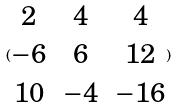Convert formula to latex. <formula><loc_0><loc_0><loc_500><loc_500>( \begin{matrix} 2 & 4 & 4 \\ - 6 & 6 & 1 2 \\ 1 0 & - 4 & - 1 6 \end{matrix} )</formula> 